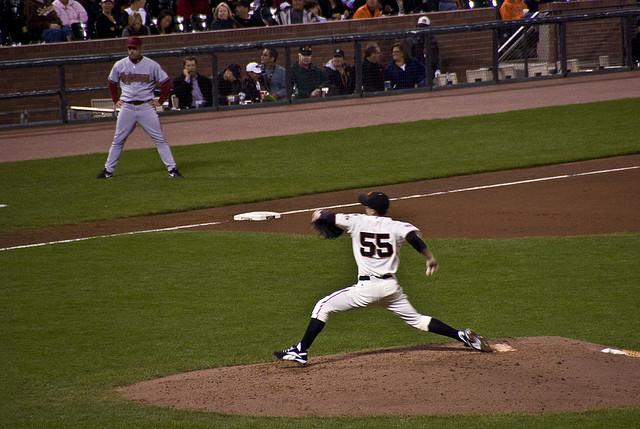What sport is being shown here?
Short answer required. Baseball. Is the person's right foot touching the ground?
Short answer required. Yes. What's the number on his back?
Short answer required. 55. 